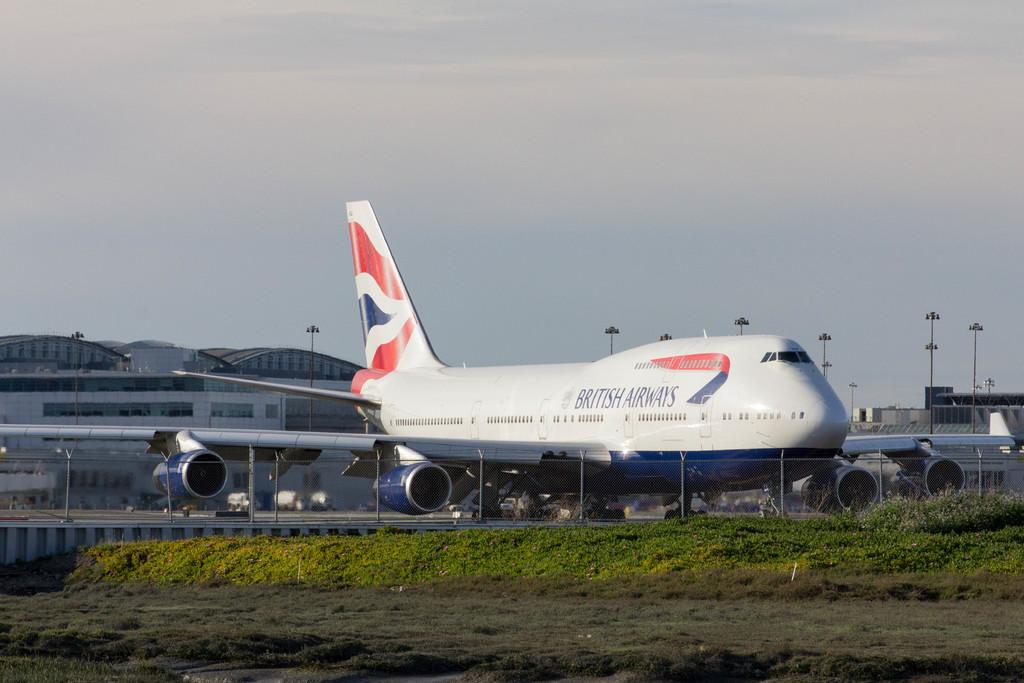<image>
Provide a brief description of the given image. A British Airways airplane is parked at the airport. 